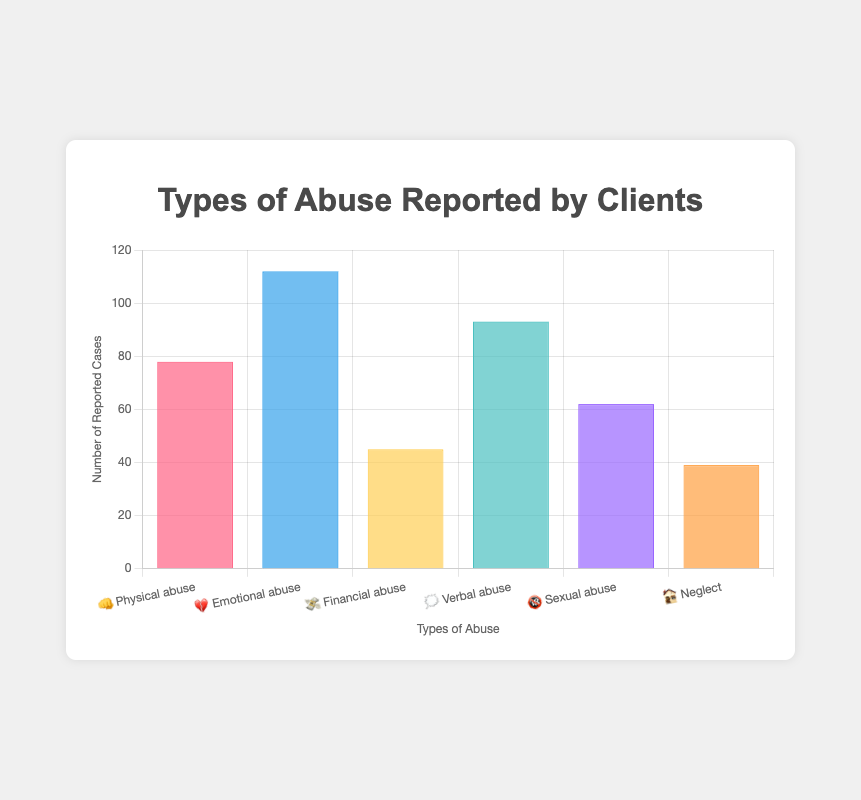How many cases of Verbal abuse were reported? The chart shows the types of abuse reported by clients with the respective number of cases. Look for the bar labeled "🗯️ Verbal abuse" and read its height on the "Reported Cases" axis.
Answer: 93 Which type of abuse has the highest number of reported cases? Compare the heights of all the bars in the chart. The bar with the greatest height represents the type of abuse with the highest number of reported cases.
Answer: Emotional abuse How many more cases of Emotional abuse are there compared to Sexual abuse? Identify the reported cases for both Emotional abuse and Sexual abuse. Emotional abuse has 112 cases, and Sexual abuse has 62 cases. Subtract the number of Sexual abuse cases from Emotional abuse cases: 112 - 62.
Answer: 50 What's the total number of reported cases for all types of abuse? Sum the reported cases for all types of abuse: 78 (Physical) + 112 (Emotional) + 45 (Financial) + 93 (Verbal) + 62 (Sexual) + 39 (Neglect).
Answer: 429 Which types of abuse have fewer than 50 reported cases? Review the number of reported cases for each type of abuse and identify those with fewer than 50 cases.
Answer: Financial abuse, Neglect Rank the types of abuse in descending order of reported cases. Order the types of abuse based on the number of reported cases from highest to lowest.
Answer: Emotional abuse, Verbal abuse, Physical abuse, Sexual abuse, Financial abuse, Neglect How many cases of both Physical abuse and Financial abuse combined were reported? Add the number of reported cases for Physical abuse and Financial abuse: 78 (Physical) + 45 (Financial).
Answer: 123 Which type of abuse has the second lowest number of reported cases? Order the types of abuse by their number of reported cases in ascending order and identify the second lowest: (1) Neglect (39), (2) Financial abuse (45).
Answer: Financial abuse 